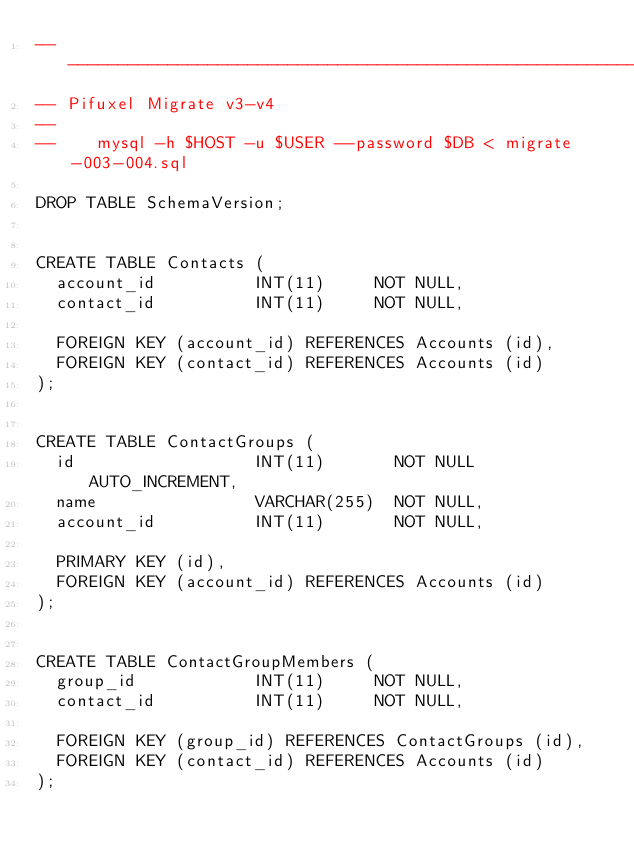Convert code to text. <code><loc_0><loc_0><loc_500><loc_500><_SQL_>-- -----------------------------------------------------------------------------
-- Pifuxel Migrate v3-v4
--
--    mysql -h $HOST -u $USER --password $DB < migrate-003-004.sql

DROP TABLE SchemaVersion;


CREATE TABLE Contacts (
  account_id          INT(11)     NOT NULL,
  contact_id          INT(11)     NOT NULL,

  FOREIGN KEY (account_id) REFERENCES Accounts (id),
  FOREIGN KEY (contact_id) REFERENCES Accounts (id)
);


CREATE TABLE ContactGroups (
  id                  INT(11)       NOT NULL AUTO_INCREMENT,
  name                VARCHAR(255)  NOT NULL,
  account_id          INT(11)       NOT NULL,

  PRIMARY KEY (id),
  FOREIGN KEY (account_id) REFERENCES Accounts (id)
);


CREATE TABLE ContactGroupMembers (
  group_id            INT(11)     NOT NULL,
  contact_id          INT(11)     NOT NULL,

  FOREIGN KEY (group_id) REFERENCES ContactGroups (id),
  FOREIGN KEY (contact_id) REFERENCES Accounts (id)
);
</code> 